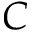<formula> <loc_0><loc_0><loc_500><loc_500>C</formula> 